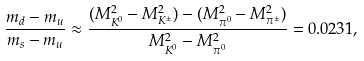<formula> <loc_0><loc_0><loc_500><loc_500>\frac { m _ { d } - m _ { u } } { m _ { s } - m _ { u } } \approx \frac { ( M ^ { 2 } _ { K ^ { 0 } } - M ^ { 2 } _ { K ^ { \pm } } ) - ( M ^ { 2 } _ { \pi ^ { 0 } } - M ^ { 2 } _ { \pi ^ { \pm } } ) } { M ^ { 2 } _ { K ^ { 0 } } - M ^ { 2 } _ { \pi ^ { 0 } } } = 0 . 0 2 3 1 ,</formula> 